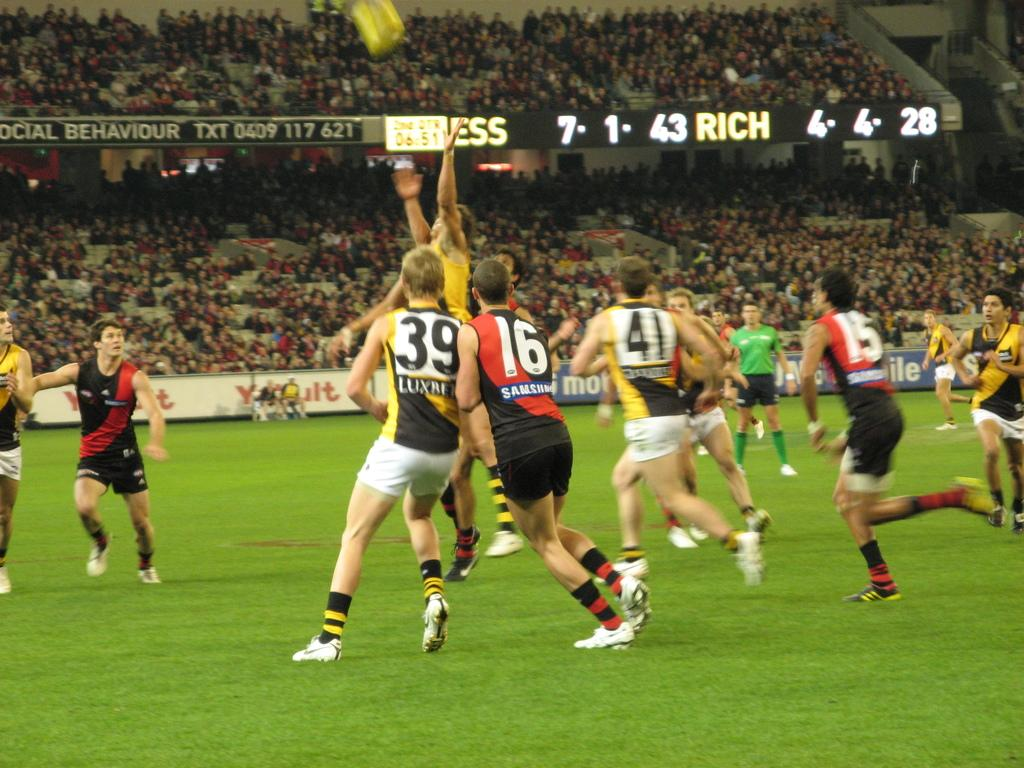Provide a one-sentence caption for the provided image. Players number 39 and 16 are touching shoulders. 